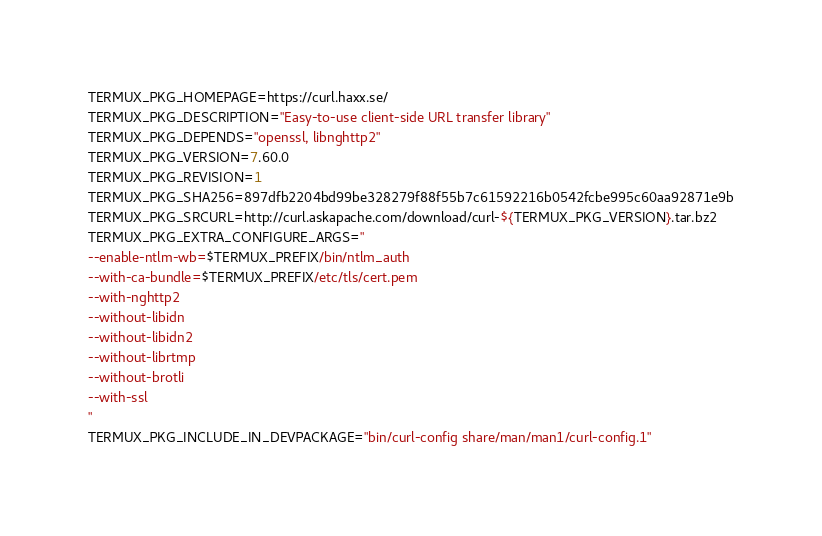Convert code to text. <code><loc_0><loc_0><loc_500><loc_500><_Bash_>TERMUX_PKG_HOMEPAGE=https://curl.haxx.se/
TERMUX_PKG_DESCRIPTION="Easy-to-use client-side URL transfer library"
TERMUX_PKG_DEPENDS="openssl, libnghttp2"
TERMUX_PKG_VERSION=7.60.0
TERMUX_PKG_REVISION=1
TERMUX_PKG_SHA256=897dfb2204bd99be328279f88f55b7c61592216b0542fcbe995c60aa92871e9b
TERMUX_PKG_SRCURL=http://curl.askapache.com/download/curl-${TERMUX_PKG_VERSION}.tar.bz2
TERMUX_PKG_EXTRA_CONFIGURE_ARGS="
--enable-ntlm-wb=$TERMUX_PREFIX/bin/ntlm_auth
--with-ca-bundle=$TERMUX_PREFIX/etc/tls/cert.pem
--with-nghttp2
--without-libidn
--without-libidn2
--without-librtmp
--without-brotli
--with-ssl
"
TERMUX_PKG_INCLUDE_IN_DEVPACKAGE="bin/curl-config share/man/man1/curl-config.1"
</code> 